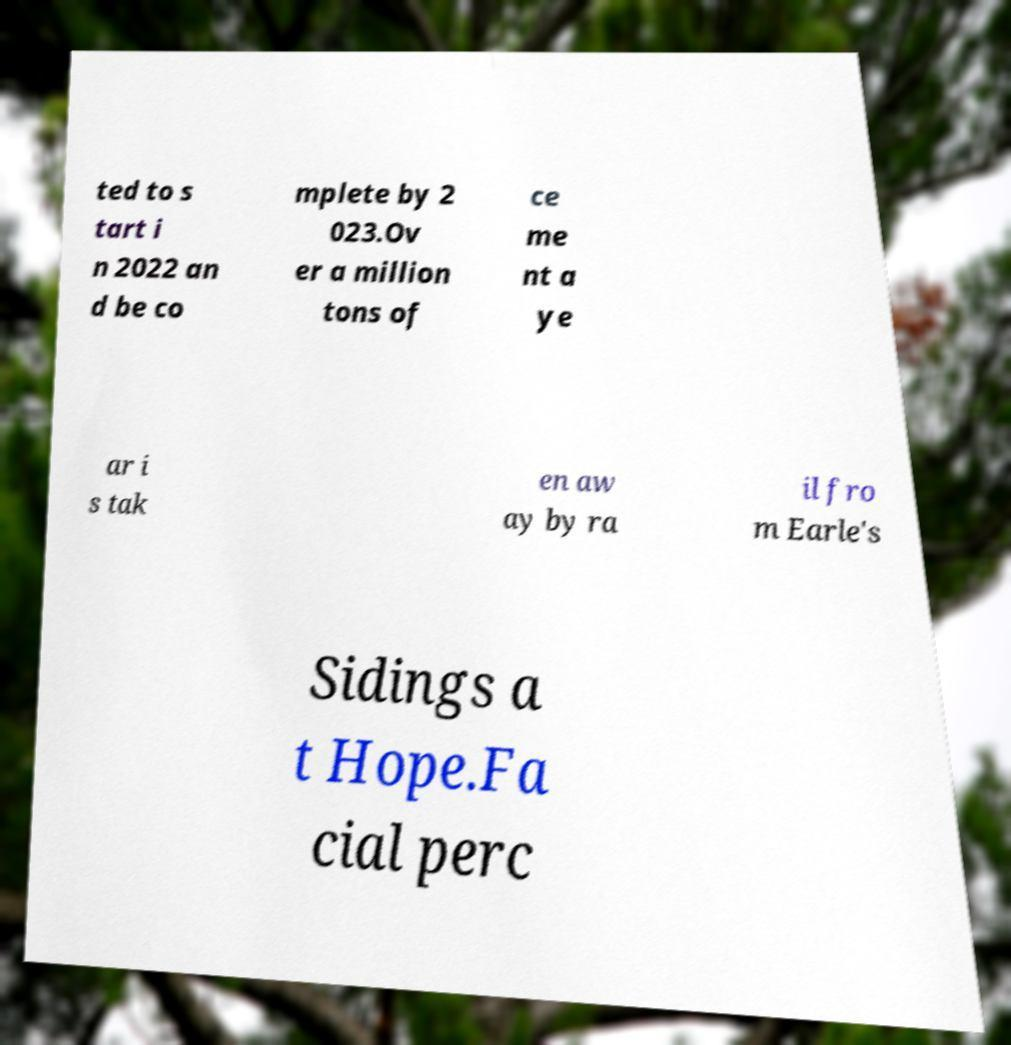There's text embedded in this image that I need extracted. Can you transcribe it verbatim? ted to s tart i n 2022 an d be co mplete by 2 023.Ov er a million tons of ce me nt a ye ar i s tak en aw ay by ra il fro m Earle's Sidings a t Hope.Fa cial perc 